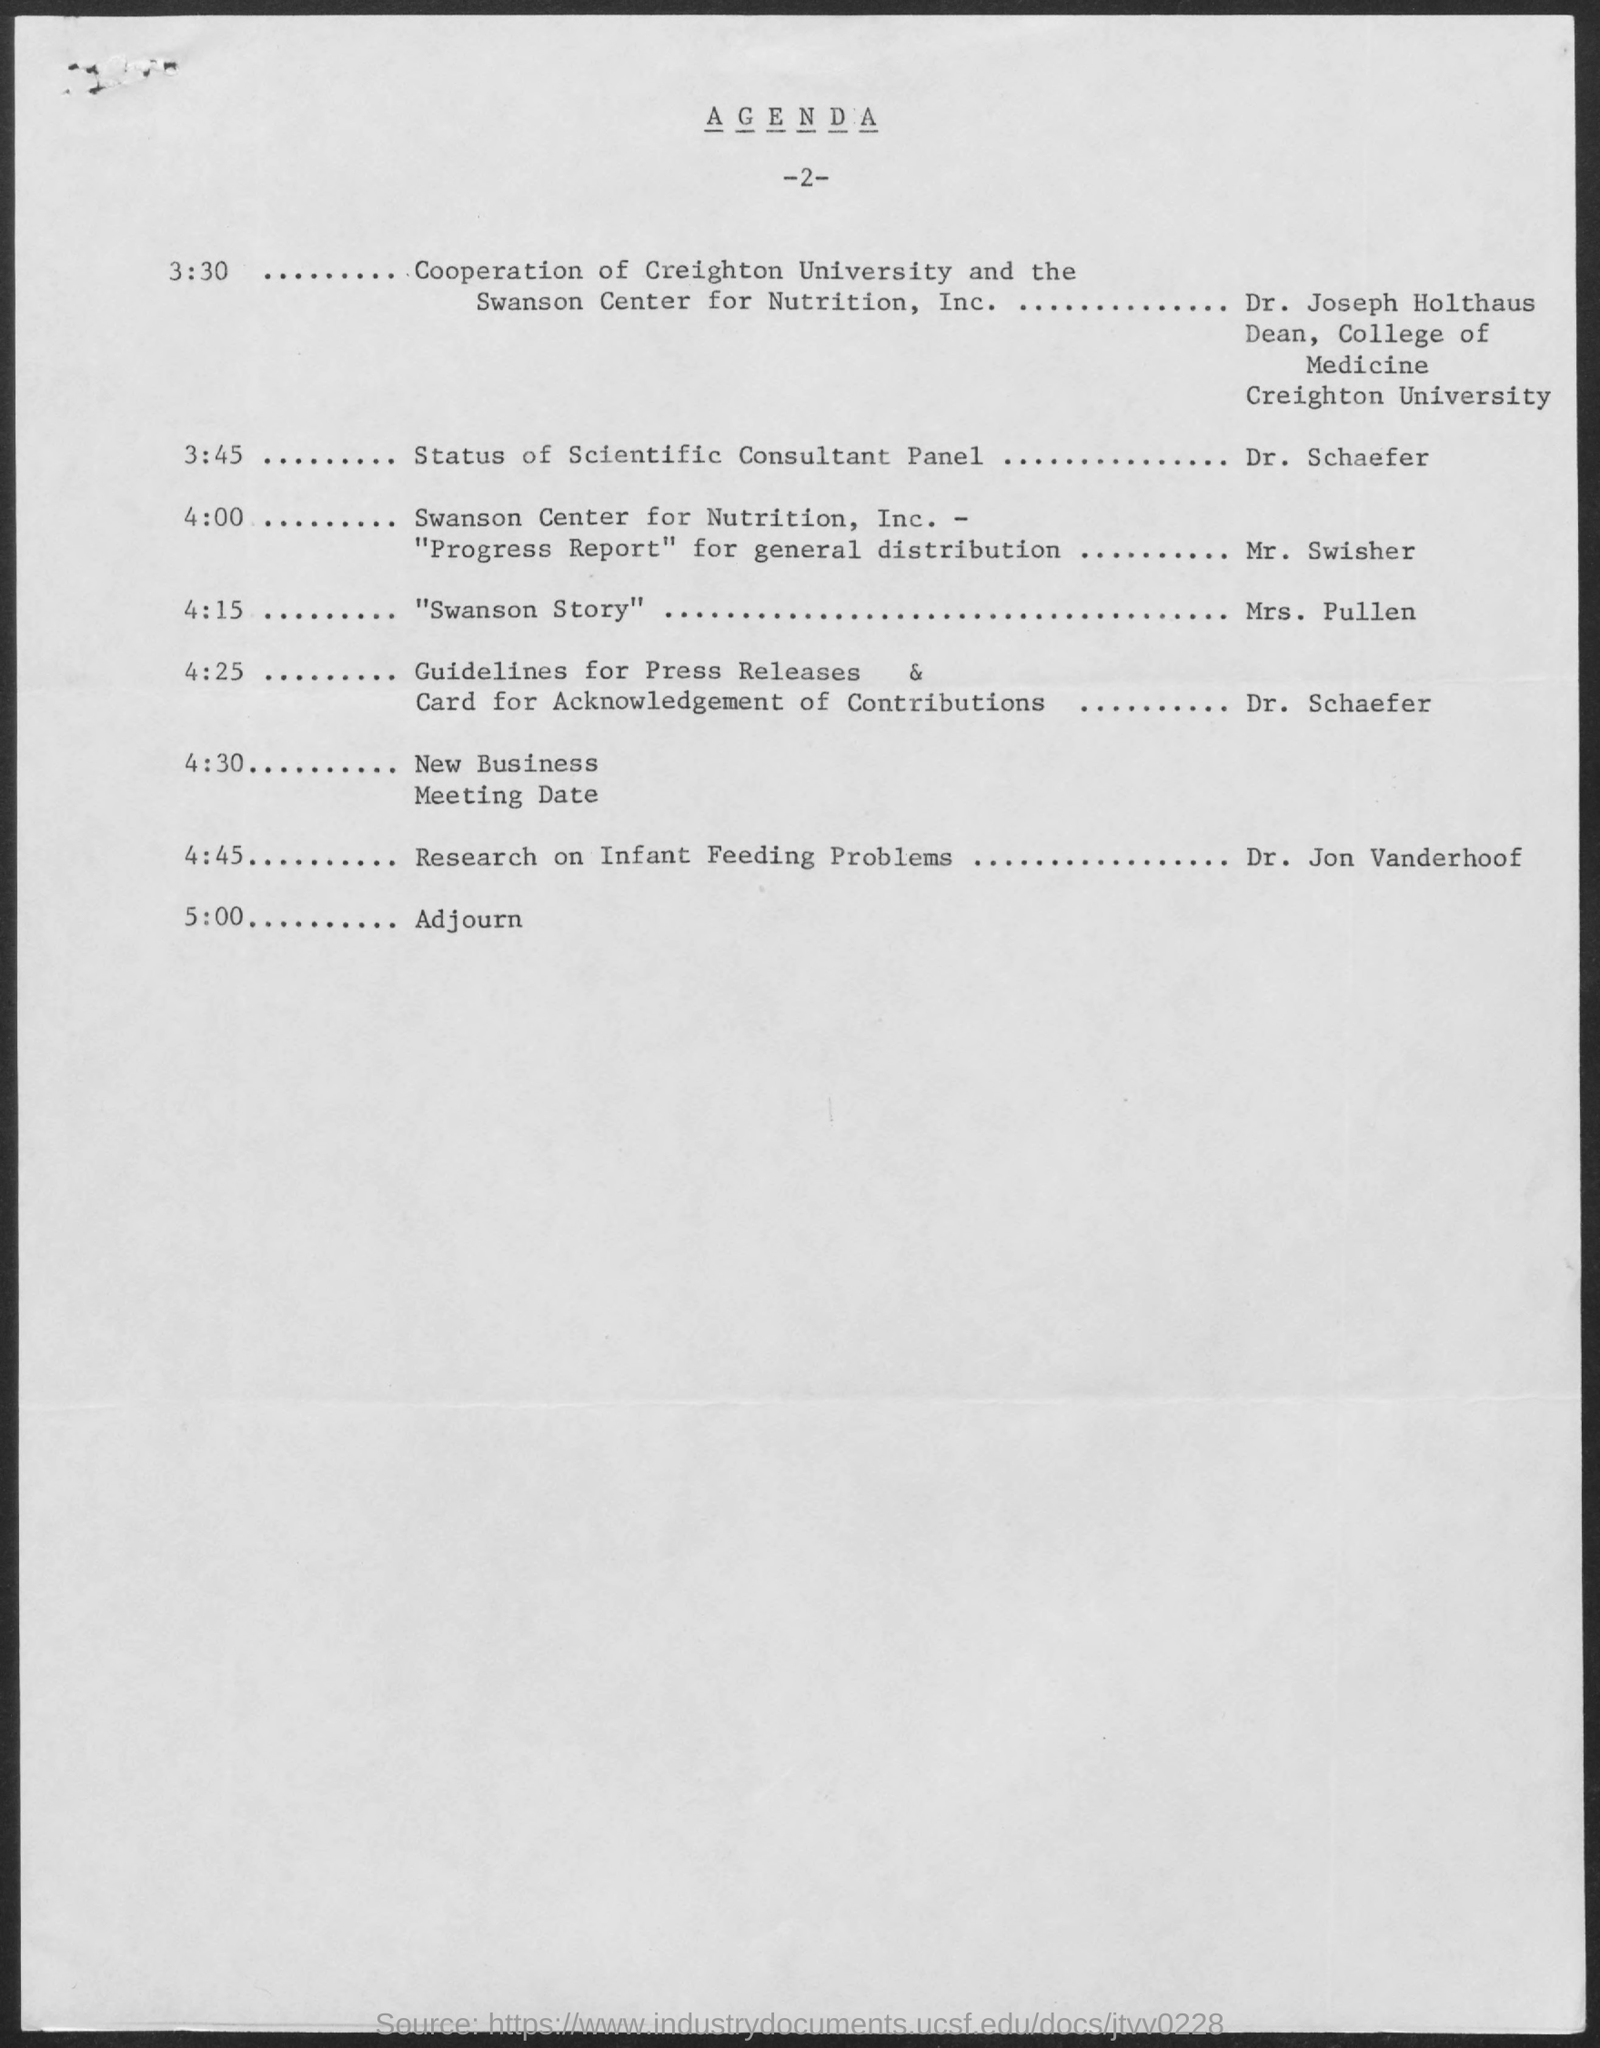What is the title of the document?
Your answer should be compact. Agenda. 